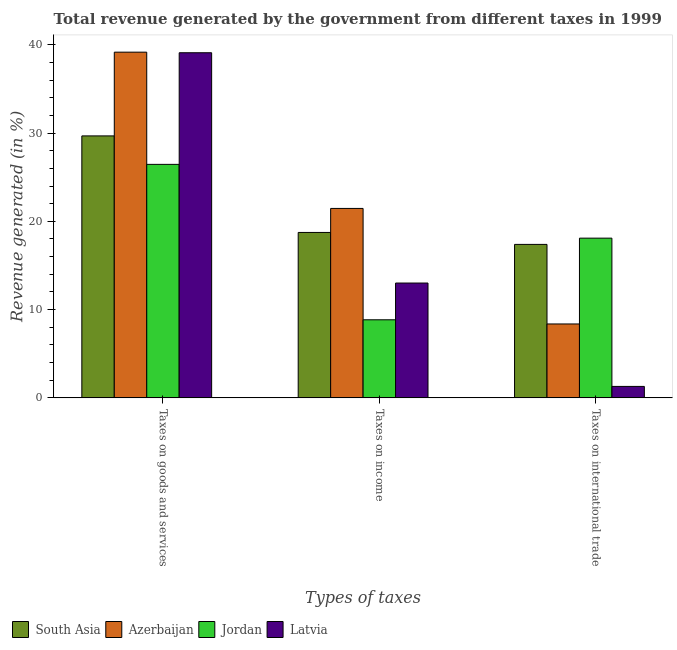How many different coloured bars are there?
Give a very brief answer. 4. How many groups of bars are there?
Your response must be concise. 3. How many bars are there on the 3rd tick from the left?
Your response must be concise. 4. How many bars are there on the 1st tick from the right?
Offer a very short reply. 4. What is the label of the 2nd group of bars from the left?
Keep it short and to the point. Taxes on income. What is the percentage of revenue generated by tax on international trade in Latvia?
Provide a succinct answer. 1.3. Across all countries, what is the maximum percentage of revenue generated by tax on international trade?
Provide a succinct answer. 18.09. Across all countries, what is the minimum percentage of revenue generated by tax on international trade?
Give a very brief answer. 1.3. In which country was the percentage of revenue generated by taxes on income maximum?
Provide a short and direct response. Azerbaijan. In which country was the percentage of revenue generated by taxes on income minimum?
Keep it short and to the point. Jordan. What is the total percentage of revenue generated by taxes on goods and services in the graph?
Keep it short and to the point. 134.39. What is the difference between the percentage of revenue generated by tax on international trade in Jordan and that in South Asia?
Offer a terse response. 0.71. What is the difference between the percentage of revenue generated by tax on international trade in Latvia and the percentage of revenue generated by taxes on income in South Asia?
Your answer should be very brief. -17.44. What is the average percentage of revenue generated by taxes on goods and services per country?
Make the answer very short. 33.6. What is the difference between the percentage of revenue generated by tax on international trade and percentage of revenue generated by taxes on income in Azerbaijan?
Provide a succinct answer. -13.09. In how many countries, is the percentage of revenue generated by tax on international trade greater than 14 %?
Offer a very short reply. 2. What is the ratio of the percentage of revenue generated by taxes on goods and services in Latvia to that in South Asia?
Your response must be concise. 1.32. What is the difference between the highest and the second highest percentage of revenue generated by taxes on goods and services?
Keep it short and to the point. 0.07. What is the difference between the highest and the lowest percentage of revenue generated by taxes on income?
Keep it short and to the point. 12.62. Is the sum of the percentage of revenue generated by taxes on income in South Asia and Azerbaijan greater than the maximum percentage of revenue generated by taxes on goods and services across all countries?
Offer a very short reply. Yes. What does the 3rd bar from the left in Taxes on goods and services represents?
Offer a terse response. Jordan. How many bars are there?
Keep it short and to the point. 12. What is the difference between two consecutive major ticks on the Y-axis?
Give a very brief answer. 10. Does the graph contain grids?
Provide a short and direct response. No. How many legend labels are there?
Your answer should be very brief. 4. How are the legend labels stacked?
Give a very brief answer. Horizontal. What is the title of the graph?
Your answer should be compact. Total revenue generated by the government from different taxes in 1999. What is the label or title of the X-axis?
Your response must be concise. Types of taxes. What is the label or title of the Y-axis?
Provide a short and direct response. Revenue generated (in %). What is the Revenue generated (in %) in South Asia in Taxes on goods and services?
Your response must be concise. 29.68. What is the Revenue generated (in %) of Azerbaijan in Taxes on goods and services?
Provide a short and direct response. 39.16. What is the Revenue generated (in %) of Jordan in Taxes on goods and services?
Your answer should be very brief. 26.45. What is the Revenue generated (in %) of Latvia in Taxes on goods and services?
Your answer should be very brief. 39.1. What is the Revenue generated (in %) of South Asia in Taxes on income?
Your answer should be very brief. 18.74. What is the Revenue generated (in %) in Azerbaijan in Taxes on income?
Offer a very short reply. 21.46. What is the Revenue generated (in %) in Jordan in Taxes on income?
Ensure brevity in your answer.  8.84. What is the Revenue generated (in %) of Latvia in Taxes on income?
Ensure brevity in your answer.  13.01. What is the Revenue generated (in %) of South Asia in Taxes on international trade?
Make the answer very short. 17.38. What is the Revenue generated (in %) in Azerbaijan in Taxes on international trade?
Your answer should be very brief. 8.37. What is the Revenue generated (in %) in Jordan in Taxes on international trade?
Give a very brief answer. 18.09. What is the Revenue generated (in %) of Latvia in Taxes on international trade?
Ensure brevity in your answer.  1.3. Across all Types of taxes, what is the maximum Revenue generated (in %) in South Asia?
Provide a short and direct response. 29.68. Across all Types of taxes, what is the maximum Revenue generated (in %) of Azerbaijan?
Your answer should be compact. 39.16. Across all Types of taxes, what is the maximum Revenue generated (in %) in Jordan?
Your response must be concise. 26.45. Across all Types of taxes, what is the maximum Revenue generated (in %) of Latvia?
Your answer should be compact. 39.1. Across all Types of taxes, what is the minimum Revenue generated (in %) in South Asia?
Provide a short and direct response. 17.38. Across all Types of taxes, what is the minimum Revenue generated (in %) of Azerbaijan?
Your answer should be very brief. 8.37. Across all Types of taxes, what is the minimum Revenue generated (in %) in Jordan?
Keep it short and to the point. 8.84. Across all Types of taxes, what is the minimum Revenue generated (in %) in Latvia?
Keep it short and to the point. 1.3. What is the total Revenue generated (in %) of South Asia in the graph?
Your answer should be compact. 65.8. What is the total Revenue generated (in %) in Azerbaijan in the graph?
Give a very brief answer. 69. What is the total Revenue generated (in %) in Jordan in the graph?
Make the answer very short. 53.39. What is the total Revenue generated (in %) of Latvia in the graph?
Your answer should be very brief. 53.4. What is the difference between the Revenue generated (in %) of South Asia in Taxes on goods and services and that in Taxes on income?
Ensure brevity in your answer.  10.94. What is the difference between the Revenue generated (in %) of Azerbaijan in Taxes on goods and services and that in Taxes on income?
Provide a short and direct response. 17.7. What is the difference between the Revenue generated (in %) in Jordan in Taxes on goods and services and that in Taxes on income?
Give a very brief answer. 17.61. What is the difference between the Revenue generated (in %) of Latvia in Taxes on goods and services and that in Taxes on income?
Provide a short and direct response. 26.09. What is the difference between the Revenue generated (in %) of South Asia in Taxes on goods and services and that in Taxes on international trade?
Your response must be concise. 12.29. What is the difference between the Revenue generated (in %) of Azerbaijan in Taxes on goods and services and that in Taxes on international trade?
Give a very brief answer. 30.79. What is the difference between the Revenue generated (in %) of Jordan in Taxes on goods and services and that in Taxes on international trade?
Give a very brief answer. 8.36. What is the difference between the Revenue generated (in %) in Latvia in Taxes on goods and services and that in Taxes on international trade?
Give a very brief answer. 37.8. What is the difference between the Revenue generated (in %) in South Asia in Taxes on income and that in Taxes on international trade?
Your response must be concise. 1.35. What is the difference between the Revenue generated (in %) of Azerbaijan in Taxes on income and that in Taxes on international trade?
Your response must be concise. 13.09. What is the difference between the Revenue generated (in %) in Jordan in Taxes on income and that in Taxes on international trade?
Provide a succinct answer. -9.25. What is the difference between the Revenue generated (in %) of Latvia in Taxes on income and that in Taxes on international trade?
Your answer should be compact. 11.71. What is the difference between the Revenue generated (in %) of South Asia in Taxes on goods and services and the Revenue generated (in %) of Azerbaijan in Taxes on income?
Give a very brief answer. 8.22. What is the difference between the Revenue generated (in %) in South Asia in Taxes on goods and services and the Revenue generated (in %) in Jordan in Taxes on income?
Give a very brief answer. 20.83. What is the difference between the Revenue generated (in %) in South Asia in Taxes on goods and services and the Revenue generated (in %) in Latvia in Taxes on income?
Your response must be concise. 16.67. What is the difference between the Revenue generated (in %) of Azerbaijan in Taxes on goods and services and the Revenue generated (in %) of Jordan in Taxes on income?
Offer a very short reply. 30.32. What is the difference between the Revenue generated (in %) of Azerbaijan in Taxes on goods and services and the Revenue generated (in %) of Latvia in Taxes on income?
Your response must be concise. 26.15. What is the difference between the Revenue generated (in %) of Jordan in Taxes on goods and services and the Revenue generated (in %) of Latvia in Taxes on income?
Provide a short and direct response. 13.44. What is the difference between the Revenue generated (in %) in South Asia in Taxes on goods and services and the Revenue generated (in %) in Azerbaijan in Taxes on international trade?
Your response must be concise. 21.3. What is the difference between the Revenue generated (in %) of South Asia in Taxes on goods and services and the Revenue generated (in %) of Jordan in Taxes on international trade?
Your answer should be compact. 11.58. What is the difference between the Revenue generated (in %) in South Asia in Taxes on goods and services and the Revenue generated (in %) in Latvia in Taxes on international trade?
Ensure brevity in your answer.  28.38. What is the difference between the Revenue generated (in %) in Azerbaijan in Taxes on goods and services and the Revenue generated (in %) in Jordan in Taxes on international trade?
Ensure brevity in your answer.  21.07. What is the difference between the Revenue generated (in %) in Azerbaijan in Taxes on goods and services and the Revenue generated (in %) in Latvia in Taxes on international trade?
Your response must be concise. 37.86. What is the difference between the Revenue generated (in %) in Jordan in Taxes on goods and services and the Revenue generated (in %) in Latvia in Taxes on international trade?
Your answer should be very brief. 25.15. What is the difference between the Revenue generated (in %) of South Asia in Taxes on income and the Revenue generated (in %) of Azerbaijan in Taxes on international trade?
Keep it short and to the point. 10.37. What is the difference between the Revenue generated (in %) in South Asia in Taxes on income and the Revenue generated (in %) in Jordan in Taxes on international trade?
Provide a short and direct response. 0.65. What is the difference between the Revenue generated (in %) of South Asia in Taxes on income and the Revenue generated (in %) of Latvia in Taxes on international trade?
Provide a succinct answer. 17.44. What is the difference between the Revenue generated (in %) of Azerbaijan in Taxes on income and the Revenue generated (in %) of Jordan in Taxes on international trade?
Provide a succinct answer. 3.37. What is the difference between the Revenue generated (in %) in Azerbaijan in Taxes on income and the Revenue generated (in %) in Latvia in Taxes on international trade?
Offer a very short reply. 20.16. What is the difference between the Revenue generated (in %) of Jordan in Taxes on income and the Revenue generated (in %) of Latvia in Taxes on international trade?
Your answer should be compact. 7.55. What is the average Revenue generated (in %) in South Asia per Types of taxes?
Make the answer very short. 21.93. What is the average Revenue generated (in %) in Azerbaijan per Types of taxes?
Your answer should be very brief. 23. What is the average Revenue generated (in %) of Jordan per Types of taxes?
Your response must be concise. 17.8. What is the average Revenue generated (in %) of Latvia per Types of taxes?
Your answer should be very brief. 17.8. What is the difference between the Revenue generated (in %) in South Asia and Revenue generated (in %) in Azerbaijan in Taxes on goods and services?
Make the answer very short. -9.49. What is the difference between the Revenue generated (in %) of South Asia and Revenue generated (in %) of Jordan in Taxes on goods and services?
Your response must be concise. 3.23. What is the difference between the Revenue generated (in %) in South Asia and Revenue generated (in %) in Latvia in Taxes on goods and services?
Your response must be concise. -9.42. What is the difference between the Revenue generated (in %) in Azerbaijan and Revenue generated (in %) in Jordan in Taxes on goods and services?
Your response must be concise. 12.71. What is the difference between the Revenue generated (in %) of Azerbaijan and Revenue generated (in %) of Latvia in Taxes on goods and services?
Your answer should be very brief. 0.07. What is the difference between the Revenue generated (in %) in Jordan and Revenue generated (in %) in Latvia in Taxes on goods and services?
Make the answer very short. -12.65. What is the difference between the Revenue generated (in %) in South Asia and Revenue generated (in %) in Azerbaijan in Taxes on income?
Keep it short and to the point. -2.72. What is the difference between the Revenue generated (in %) in South Asia and Revenue generated (in %) in Jordan in Taxes on income?
Give a very brief answer. 9.89. What is the difference between the Revenue generated (in %) of South Asia and Revenue generated (in %) of Latvia in Taxes on income?
Provide a succinct answer. 5.73. What is the difference between the Revenue generated (in %) in Azerbaijan and Revenue generated (in %) in Jordan in Taxes on income?
Offer a very short reply. 12.62. What is the difference between the Revenue generated (in %) of Azerbaijan and Revenue generated (in %) of Latvia in Taxes on income?
Offer a very short reply. 8.45. What is the difference between the Revenue generated (in %) in Jordan and Revenue generated (in %) in Latvia in Taxes on income?
Ensure brevity in your answer.  -4.16. What is the difference between the Revenue generated (in %) of South Asia and Revenue generated (in %) of Azerbaijan in Taxes on international trade?
Your response must be concise. 9.01. What is the difference between the Revenue generated (in %) in South Asia and Revenue generated (in %) in Jordan in Taxes on international trade?
Provide a succinct answer. -0.71. What is the difference between the Revenue generated (in %) in South Asia and Revenue generated (in %) in Latvia in Taxes on international trade?
Give a very brief answer. 16.09. What is the difference between the Revenue generated (in %) of Azerbaijan and Revenue generated (in %) of Jordan in Taxes on international trade?
Provide a succinct answer. -9.72. What is the difference between the Revenue generated (in %) of Azerbaijan and Revenue generated (in %) of Latvia in Taxes on international trade?
Offer a terse response. 7.07. What is the difference between the Revenue generated (in %) in Jordan and Revenue generated (in %) in Latvia in Taxes on international trade?
Your answer should be very brief. 16.8. What is the ratio of the Revenue generated (in %) in South Asia in Taxes on goods and services to that in Taxes on income?
Offer a terse response. 1.58. What is the ratio of the Revenue generated (in %) of Azerbaijan in Taxes on goods and services to that in Taxes on income?
Make the answer very short. 1.82. What is the ratio of the Revenue generated (in %) of Jordan in Taxes on goods and services to that in Taxes on income?
Give a very brief answer. 2.99. What is the ratio of the Revenue generated (in %) in Latvia in Taxes on goods and services to that in Taxes on income?
Provide a short and direct response. 3.01. What is the ratio of the Revenue generated (in %) in South Asia in Taxes on goods and services to that in Taxes on international trade?
Ensure brevity in your answer.  1.71. What is the ratio of the Revenue generated (in %) of Azerbaijan in Taxes on goods and services to that in Taxes on international trade?
Keep it short and to the point. 4.68. What is the ratio of the Revenue generated (in %) of Jordan in Taxes on goods and services to that in Taxes on international trade?
Offer a terse response. 1.46. What is the ratio of the Revenue generated (in %) of Latvia in Taxes on goods and services to that in Taxes on international trade?
Your response must be concise. 30.11. What is the ratio of the Revenue generated (in %) of South Asia in Taxes on income to that in Taxes on international trade?
Keep it short and to the point. 1.08. What is the ratio of the Revenue generated (in %) of Azerbaijan in Taxes on income to that in Taxes on international trade?
Your response must be concise. 2.56. What is the ratio of the Revenue generated (in %) in Jordan in Taxes on income to that in Taxes on international trade?
Your answer should be compact. 0.49. What is the ratio of the Revenue generated (in %) in Latvia in Taxes on income to that in Taxes on international trade?
Provide a succinct answer. 10.02. What is the difference between the highest and the second highest Revenue generated (in %) of South Asia?
Offer a terse response. 10.94. What is the difference between the highest and the second highest Revenue generated (in %) of Azerbaijan?
Give a very brief answer. 17.7. What is the difference between the highest and the second highest Revenue generated (in %) of Jordan?
Provide a short and direct response. 8.36. What is the difference between the highest and the second highest Revenue generated (in %) of Latvia?
Offer a very short reply. 26.09. What is the difference between the highest and the lowest Revenue generated (in %) of South Asia?
Your answer should be very brief. 12.29. What is the difference between the highest and the lowest Revenue generated (in %) of Azerbaijan?
Make the answer very short. 30.79. What is the difference between the highest and the lowest Revenue generated (in %) in Jordan?
Give a very brief answer. 17.61. What is the difference between the highest and the lowest Revenue generated (in %) in Latvia?
Provide a succinct answer. 37.8. 